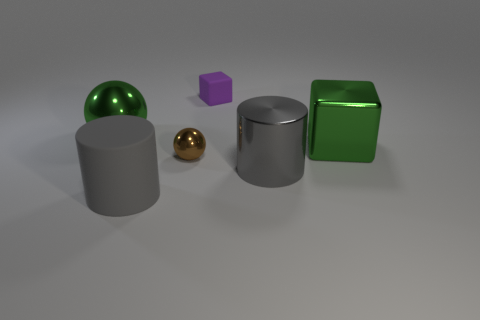Add 4 large gray things. How many objects exist? 10 Subtract all cylinders. How many objects are left? 4 Add 5 large green balls. How many large green balls are left? 6 Add 5 gray matte objects. How many gray matte objects exist? 6 Subtract 0 blue cylinders. How many objects are left? 6 Subtract all metal balls. Subtract all big blocks. How many objects are left? 3 